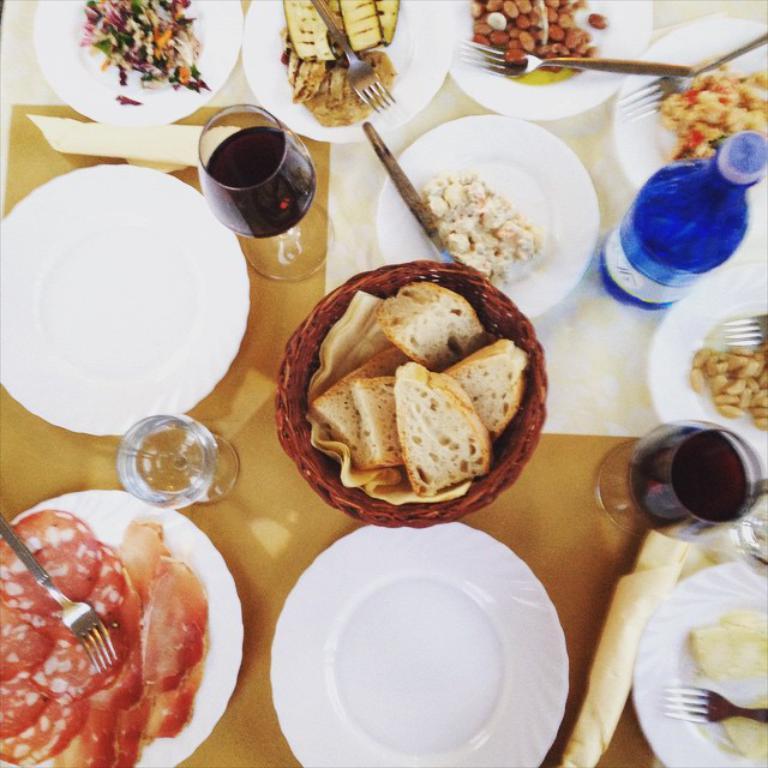Can you describe this image briefly? In the image we can see a table, on the table there are some plates, bottles, glasses and spoons and forks and food. 